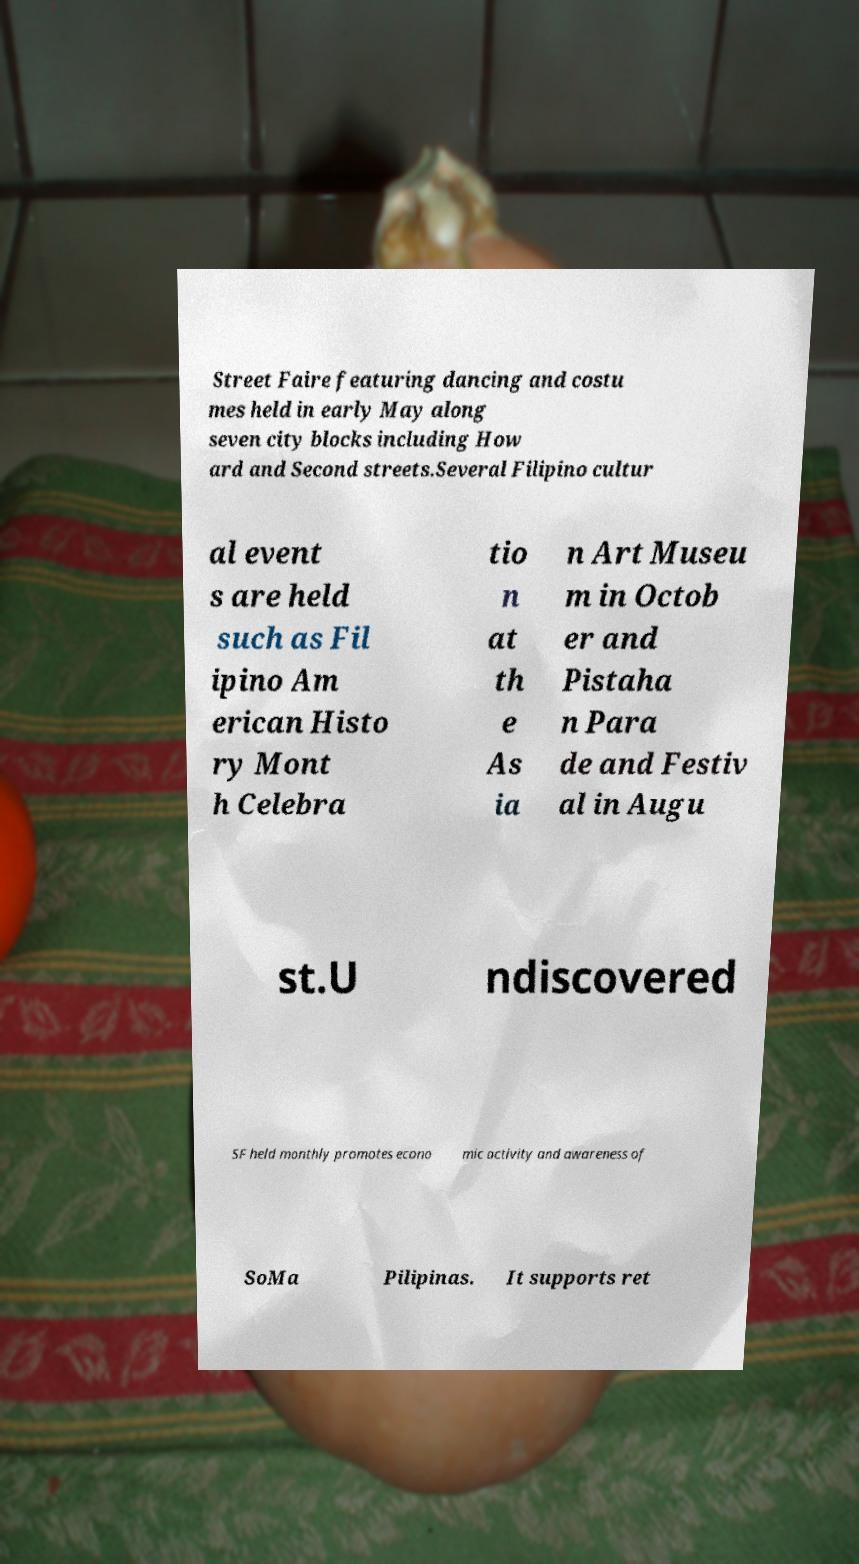Could you extract and type out the text from this image? Street Faire featuring dancing and costu mes held in early May along seven city blocks including How ard and Second streets.Several Filipino cultur al event s are held such as Fil ipino Am erican Histo ry Mont h Celebra tio n at th e As ia n Art Museu m in Octob er and Pistaha n Para de and Festiv al in Augu st.U ndiscovered SF held monthly promotes econo mic activity and awareness of SoMa Pilipinas. It supports ret 